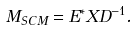Convert formula to latex. <formula><loc_0><loc_0><loc_500><loc_500>M _ { S C M } = E ^ { * } X D ^ { - 1 } .</formula> 